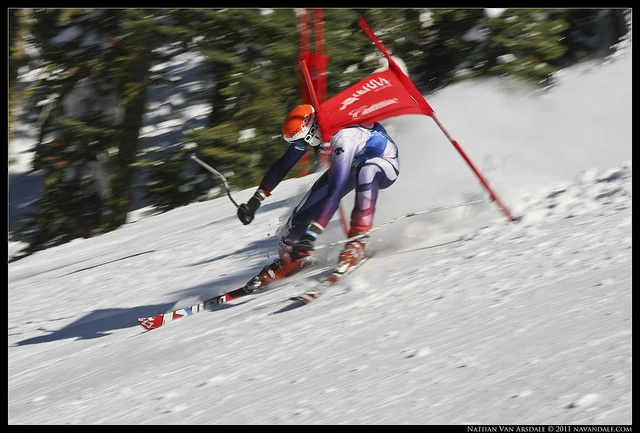Describe the objects in this image and their specific colors. I can see people in black, gray, lightgray, and darkgray tones and skis in black, darkgray, lightgray, and gray tones in this image. 